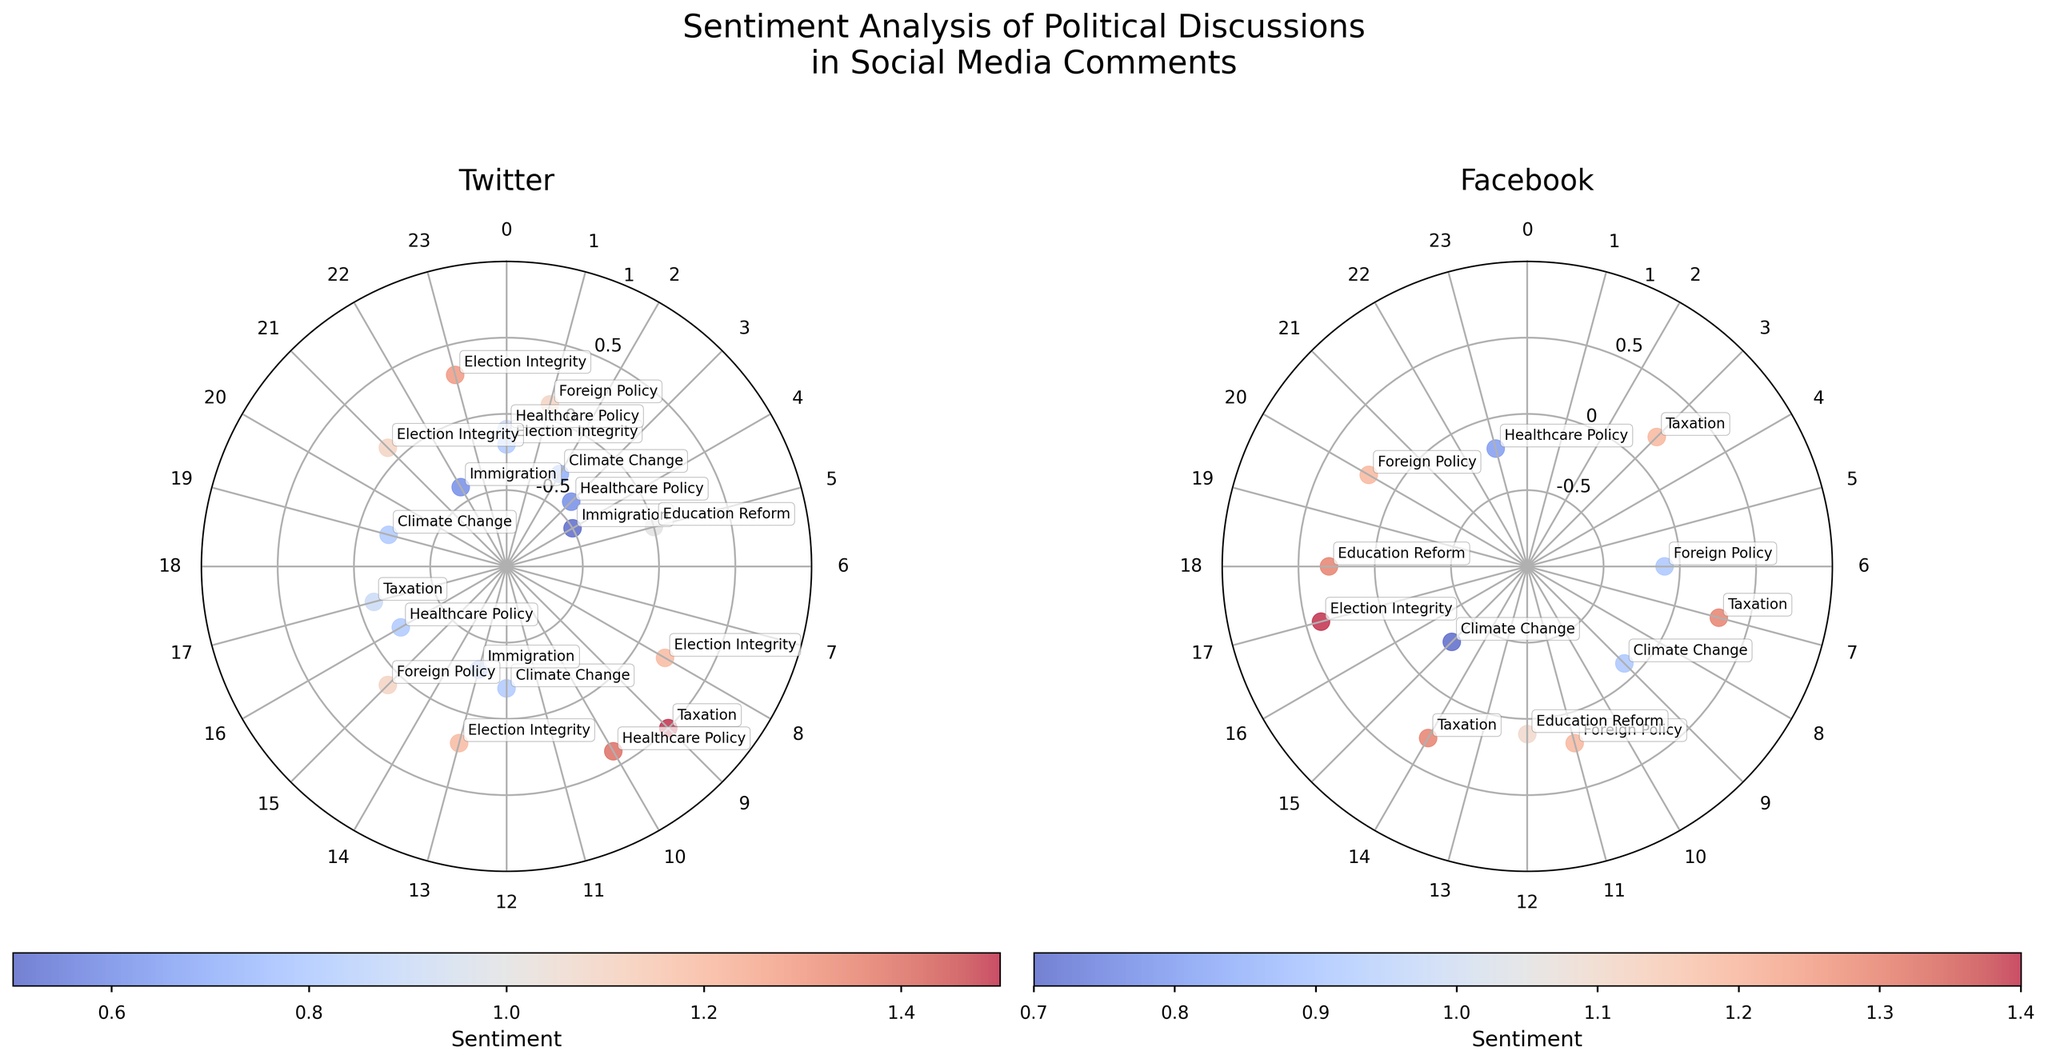Which platform shows more positive sentiment discussions overall? To determine which platform shows more positive sentiment, look at the color spread in each subplot. The colors indicate sentiment—blue tones for negative, red tones for positive. Generally, Facebook has more data points in reds and pinks, indicating higher positive sentiment.
Answer: Facebook What's the title of the plot? The title of the plot is written at the top, summarizing the entire figure. The title is "Sentiment Analysis of Political Discussions in Social Media Comments."
Answer: Sentiment Analysis of Political Discussions in Social Media Comments At what hours do we see highly negative sentiments in the discussions about immigration on Twitter? Check the subplot for Twitter and look for points closest to the center (indicating high negativity) with the annotation "Immigration." These occur at hours 4, 13, and 22.
Answer: 4, 13, 22 Which discussion topic on Facebook shows the highest positive sentiment? Observing the subplot for Facebook, identify the data point farthest from the center with the highest sentiment value. The topic annotated is "Election Integrity" around the 17th hour.
Answer: Election Integrity What is the average sentiment of discussions about Climate Change on Twitter? Identify all the points annotated with "Climate Change" on the Twitter subplot (hours 2, 12, 19) and calculate the average sentiment: (-0.3 + -0.2 + -0.2) / 3 = -0.2333.
Answer: -0.2333 Compare the sentiment of Foreign Policy discussions on different platforms. Which platform has a more positive sentiment on average? Consider all points annotated "Foreign Policy" on both subplots. For Twitter (hours 1, 15), the sentiments are 0.1 and 0.1. For Facebook (hours 6, 11, 20), the sentiments are -0.1, 0.2, 0.2. Average for Twitter = (0.1 + 0.1) / 2 = 0.1. Average for Facebook = (-0.1 + 0.2 + 0.2) / 3 = 0.1. Since both platforms have the same average sentiment, neither has a more positive sentiment.
Answer: Neither Which platform has the most discussions with a sentiment of zero for any topic? Look at both subplots and identify the data points exactly on the midpoint of the radial axis (r = 1). There is one such data point on Twitter (hour 5 for Education Reform) and none on Facebook.
Answer: Twitter What is the distribution pattern of discussion topics on Facebook compared to Twitter? Analyze the spread and diversity of the annotations around the circles in each subplot. Facebook shows more clustered and high-sentiment discussions, while Twitter has a wider spread with both high and low sentiments.
Answer: More clustered and positive on Facebook, wider spread on Twitter What's the sentiment trend across hours for topics on Twitter? Observe the radial positions of data points in Twitters's subplot. Early hours (0-6) tend to be more negative, while the middle hours (8-12) show positive sentiment. Late hours (18-23) again show mixed sentiment.
Answer: Early negative, middle positive, late mixed 